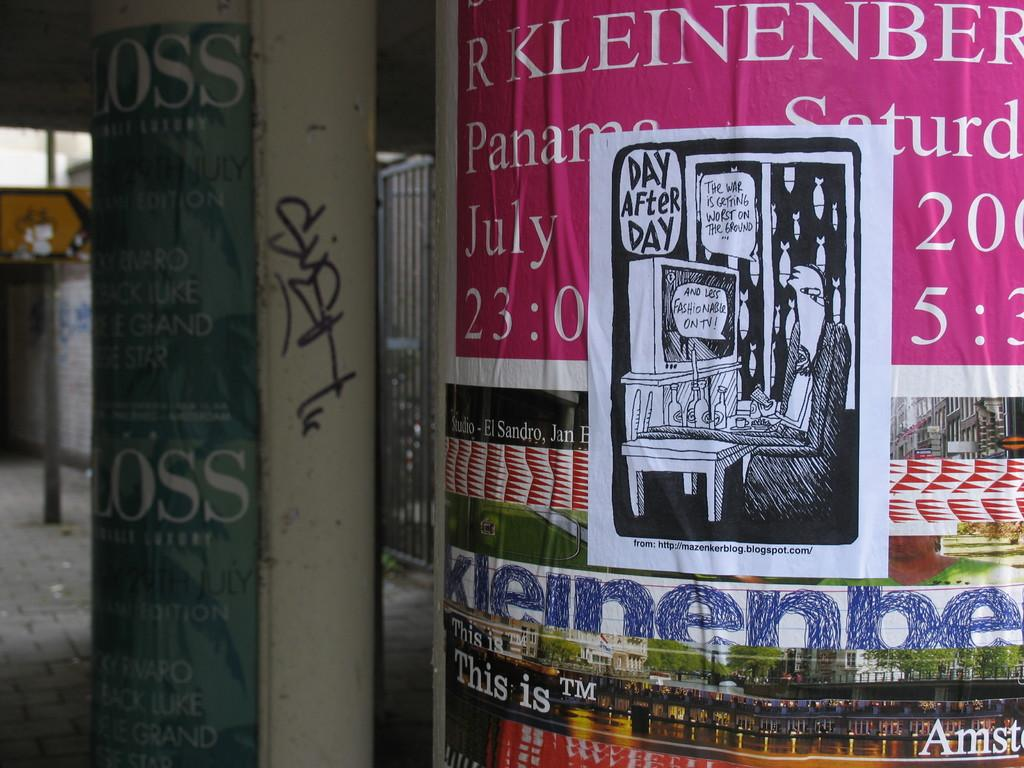<image>
Render a clear and concise summary of the photo. A black and white paper says day after day. 